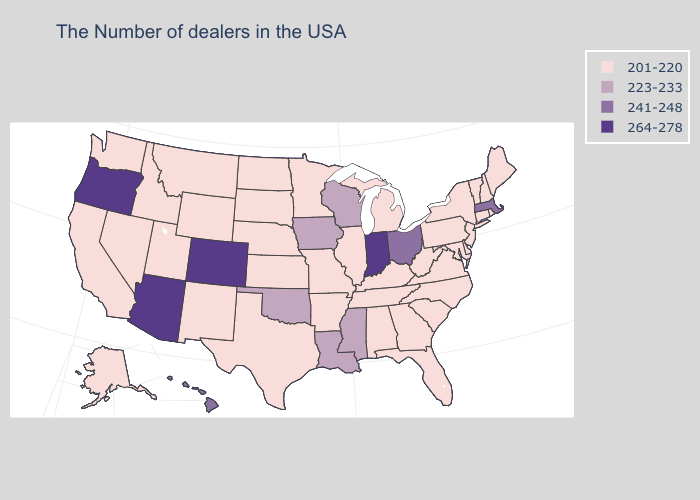Name the states that have a value in the range 264-278?
Keep it brief. Indiana, Colorado, Arizona, Oregon. Does the first symbol in the legend represent the smallest category?
Answer briefly. Yes. Does the map have missing data?
Quick response, please. No. What is the highest value in states that border Michigan?
Answer briefly. 264-278. What is the value of Oregon?
Answer briefly. 264-278. Does the map have missing data?
Answer briefly. No. What is the value of Washington?
Concise answer only. 201-220. Which states hav the highest value in the West?
Quick response, please. Colorado, Arizona, Oregon. Name the states that have a value in the range 223-233?
Be succinct. Wisconsin, Mississippi, Louisiana, Iowa, Oklahoma. What is the lowest value in the MidWest?
Quick response, please. 201-220. Among the states that border Ohio , which have the highest value?
Give a very brief answer. Indiana. Among the states that border New Hampshire , does Maine have the highest value?
Quick response, please. No. What is the value of California?
Keep it brief. 201-220. What is the value of Wyoming?
Short answer required. 201-220. 